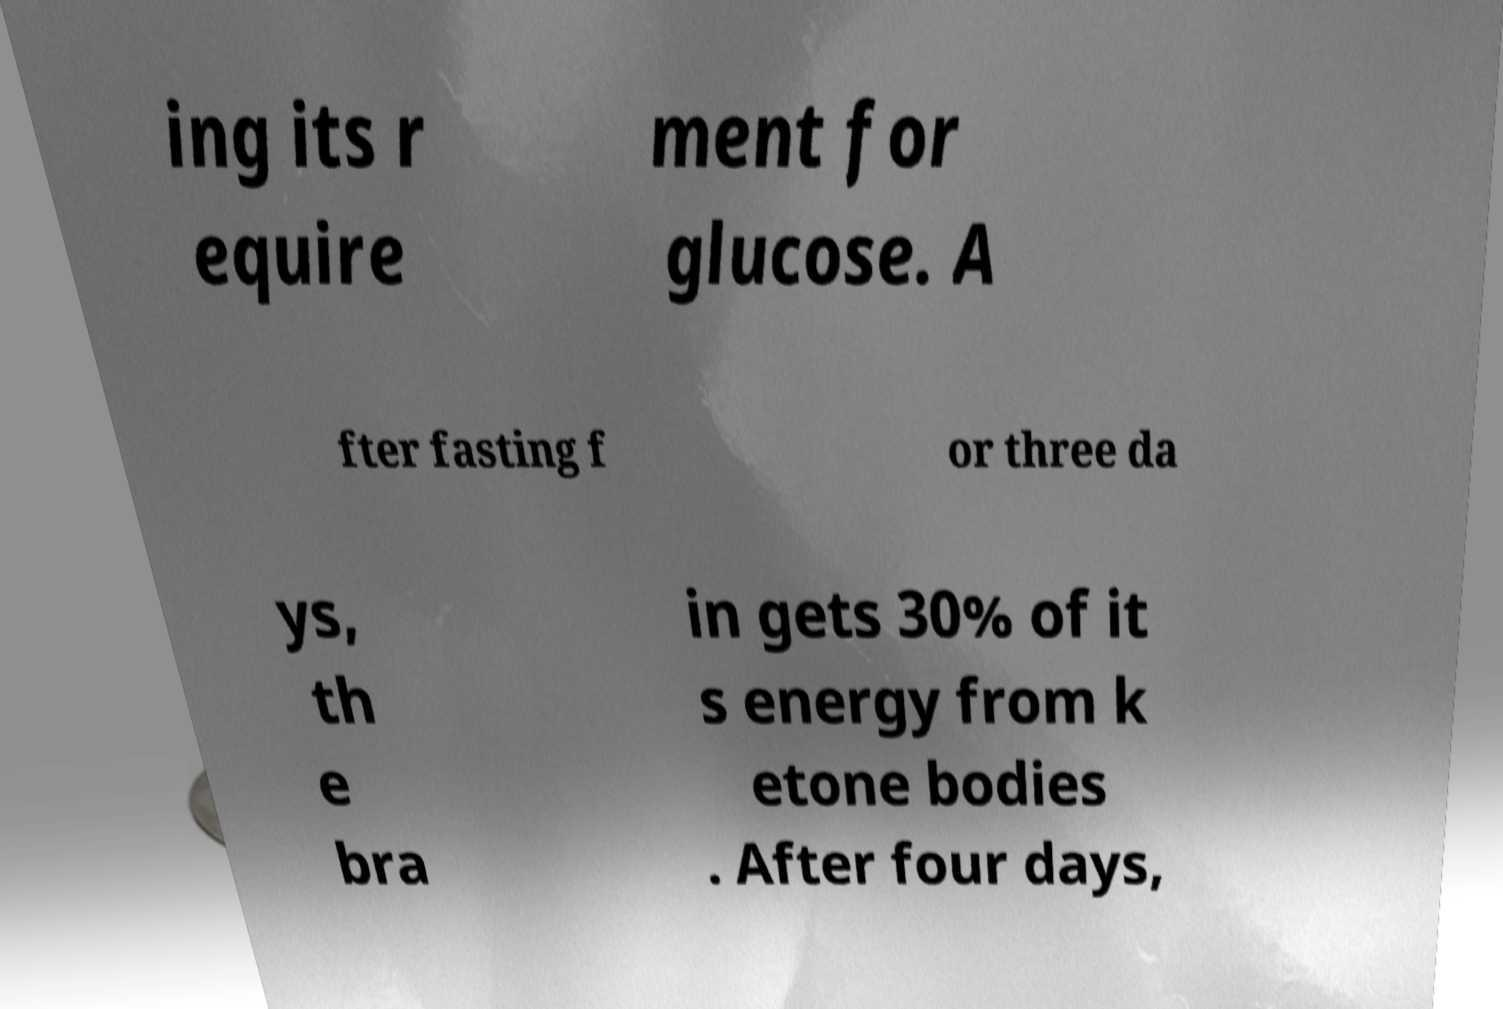Please read and relay the text visible in this image. What does it say? ing its r equire ment for glucose. A fter fasting f or three da ys, th e bra in gets 30% of it s energy from k etone bodies . After four days, 